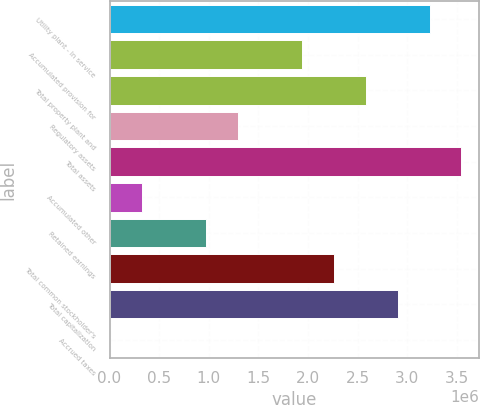Convert chart to OTSL. <chart><loc_0><loc_0><loc_500><loc_500><bar_chart><fcel>Utility plant - In service<fcel>Accumulated provision for<fcel>Total property plant and<fcel>Regulatory assets<fcel>Total assets<fcel>Accumulated other<fcel>Retained earnings<fcel>Total common stockholder's<fcel>Total capitalization<fcel>Accrued taxes<nl><fcel>3.22455e+06<fcel>1.93734e+06<fcel>2.58094e+06<fcel>1.29374e+06<fcel>3.54635e+06<fcel>328333<fcel>971936<fcel>2.25914e+06<fcel>2.90275e+06<fcel>6531<nl></chart> 